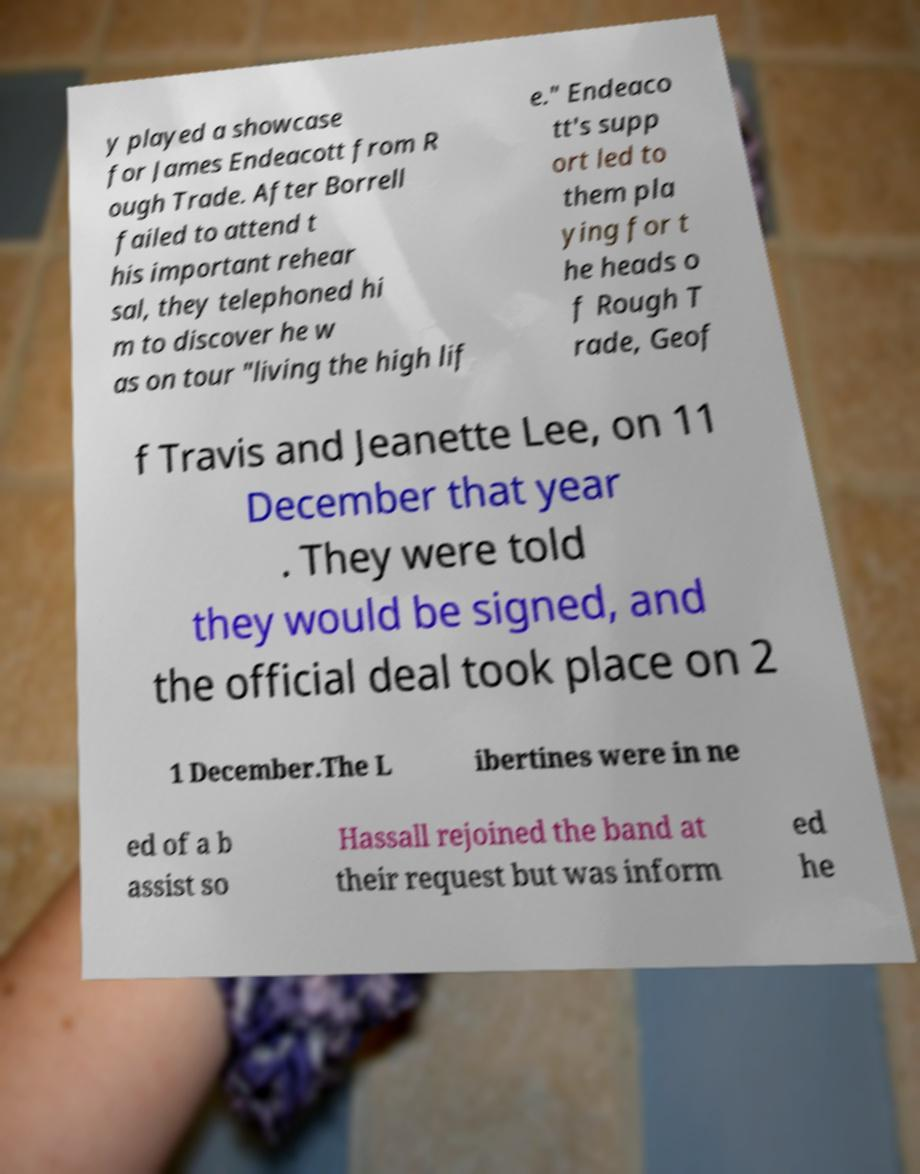Could you assist in decoding the text presented in this image and type it out clearly? y played a showcase for James Endeacott from R ough Trade. After Borrell failed to attend t his important rehear sal, they telephoned hi m to discover he w as on tour "living the high lif e." Endeaco tt's supp ort led to them pla ying for t he heads o f Rough T rade, Geof f Travis and Jeanette Lee, on 11 December that year . They were told they would be signed, and the official deal took place on 2 1 December.The L ibertines were in ne ed of a b assist so Hassall rejoined the band at their request but was inform ed he 